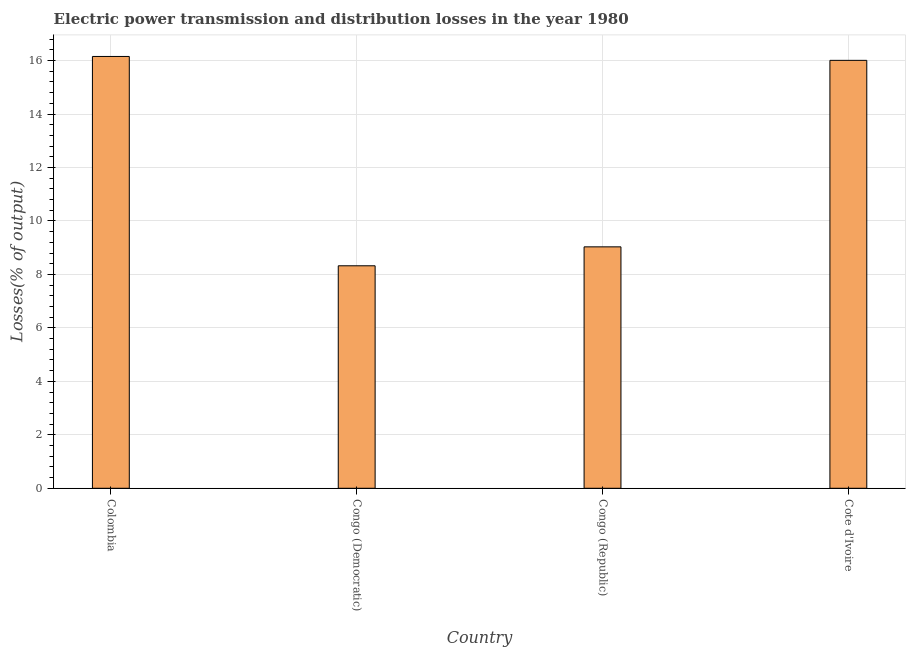What is the title of the graph?
Make the answer very short. Electric power transmission and distribution losses in the year 1980. What is the label or title of the Y-axis?
Provide a short and direct response. Losses(% of output). What is the electric power transmission and distribution losses in Congo (Democratic)?
Offer a very short reply. 8.32. Across all countries, what is the maximum electric power transmission and distribution losses?
Offer a very short reply. 16.15. Across all countries, what is the minimum electric power transmission and distribution losses?
Ensure brevity in your answer.  8.32. In which country was the electric power transmission and distribution losses maximum?
Make the answer very short. Colombia. In which country was the electric power transmission and distribution losses minimum?
Offer a very short reply. Congo (Democratic). What is the sum of the electric power transmission and distribution losses?
Keep it short and to the point. 49.52. What is the difference between the electric power transmission and distribution losses in Congo (Republic) and Cote d'Ivoire?
Make the answer very short. -6.98. What is the average electric power transmission and distribution losses per country?
Offer a very short reply. 12.38. What is the median electric power transmission and distribution losses?
Provide a succinct answer. 12.52. In how many countries, is the electric power transmission and distribution losses greater than 7.2 %?
Your answer should be very brief. 4. What is the ratio of the electric power transmission and distribution losses in Congo (Republic) to that in Cote d'Ivoire?
Provide a short and direct response. 0.56. What is the difference between the highest and the second highest electric power transmission and distribution losses?
Your answer should be very brief. 0.15. What is the difference between the highest and the lowest electric power transmission and distribution losses?
Your response must be concise. 7.83. In how many countries, is the electric power transmission and distribution losses greater than the average electric power transmission and distribution losses taken over all countries?
Keep it short and to the point. 2. How many countries are there in the graph?
Offer a terse response. 4. What is the Losses(% of output) of Colombia?
Provide a short and direct response. 16.15. What is the Losses(% of output) in Congo (Democratic)?
Offer a very short reply. 8.32. What is the Losses(% of output) of Congo (Republic)?
Your response must be concise. 9.03. What is the Losses(% of output) in Cote d'Ivoire?
Offer a very short reply. 16.01. What is the difference between the Losses(% of output) in Colombia and Congo (Democratic)?
Keep it short and to the point. 7.83. What is the difference between the Losses(% of output) in Colombia and Congo (Republic)?
Provide a succinct answer. 7.12. What is the difference between the Losses(% of output) in Colombia and Cote d'Ivoire?
Provide a succinct answer. 0.15. What is the difference between the Losses(% of output) in Congo (Democratic) and Congo (Republic)?
Your answer should be very brief. -0.71. What is the difference between the Losses(% of output) in Congo (Democratic) and Cote d'Ivoire?
Provide a succinct answer. -7.69. What is the difference between the Losses(% of output) in Congo (Republic) and Cote d'Ivoire?
Your answer should be compact. -6.98. What is the ratio of the Losses(% of output) in Colombia to that in Congo (Democratic)?
Offer a very short reply. 1.94. What is the ratio of the Losses(% of output) in Colombia to that in Congo (Republic)?
Your answer should be compact. 1.79. What is the ratio of the Losses(% of output) in Congo (Democratic) to that in Congo (Republic)?
Give a very brief answer. 0.92. What is the ratio of the Losses(% of output) in Congo (Democratic) to that in Cote d'Ivoire?
Provide a succinct answer. 0.52. What is the ratio of the Losses(% of output) in Congo (Republic) to that in Cote d'Ivoire?
Your answer should be compact. 0.56. 